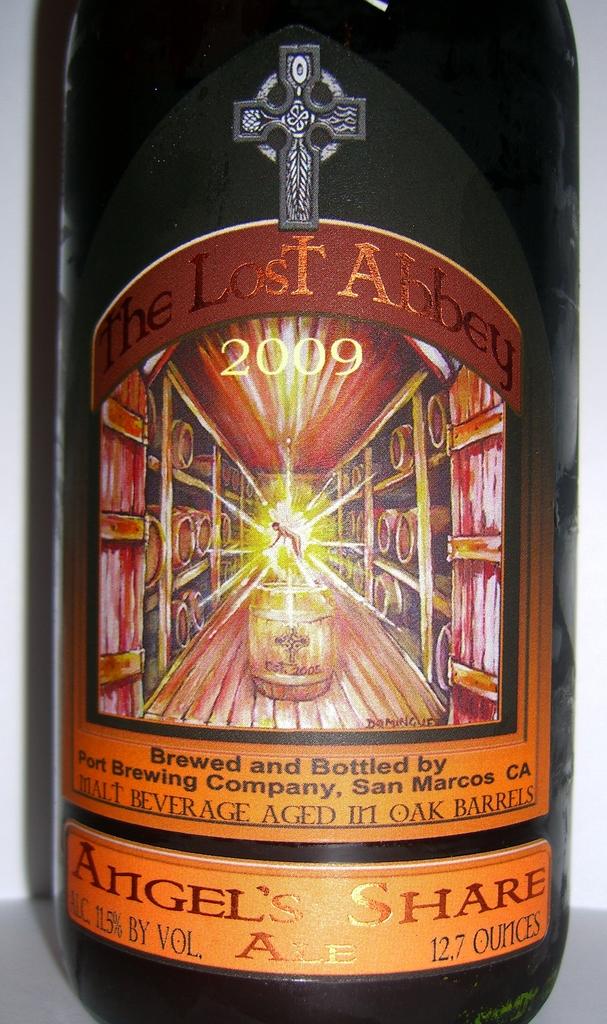What year is this malt beverage from?
Your answer should be very brief. 2009. How many ounces is this bottle?
Provide a short and direct response. 12.7. 